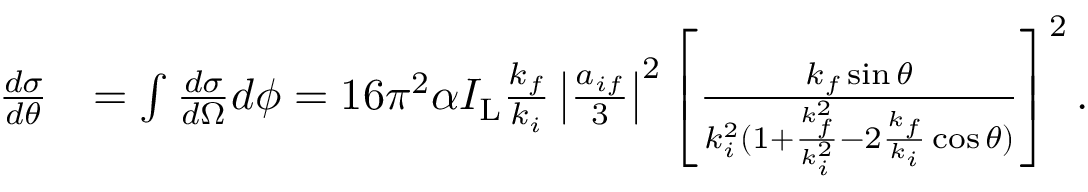Convert formula to latex. <formula><loc_0><loc_0><loc_500><loc_500>\begin{array} { r l } { \frac { d \sigma } { d \theta } } & { = \int \frac { d \sigma } { d \Omega } d \phi = 1 6 \pi ^ { 2 } \alpha I _ { L } \frac { k _ { f } } { k _ { i } } \left | \frac { a _ { i f } } { 3 } \right | ^ { 2 } \left [ \frac { k _ { f } \sin \theta } { k _ { i } ^ { 2 } ( 1 + \frac { k _ { f } ^ { 2 } } { k _ { i } ^ { 2 } } - 2 \frac { k _ { f } } { k _ { i } } \cos \theta ) } \right ] ^ { 2 } . } \end{array}</formula> 